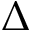<formula> <loc_0><loc_0><loc_500><loc_500>\Delta</formula> 